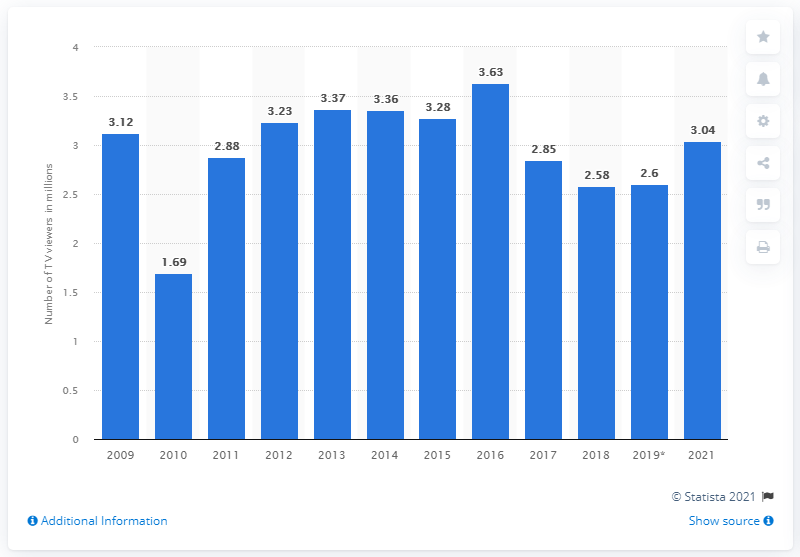Mention a couple of crucial points in this snapshot. In 2019, the Eurovision Song Contest was watched by 2.6 million people. The number of people who watched the last broadcast of the Eurovision Song Contest was 3,040. The number of viewers of the Eurovision Song Contest increased to 2021. 